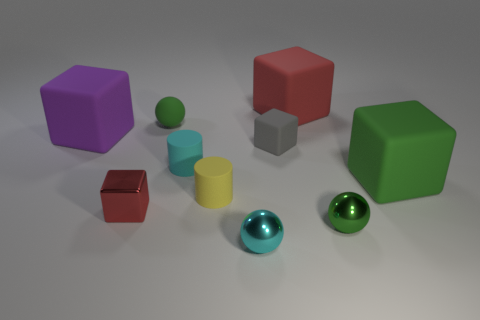The small sphere that is the same material as the small yellow object is what color?
Your answer should be compact. Green. Does the small matte thing to the right of the cyan shiny thing have the same shape as the yellow rubber thing?
Your answer should be compact. No. What number of objects are either tiny green balls behind the large green cube or tiny metal things on the left side of the tiny green metal ball?
Offer a very short reply. 3. There is another small rubber thing that is the same shape as the purple rubber thing; what color is it?
Your response must be concise. Gray. Is there anything else that has the same shape as the big green object?
Offer a terse response. Yes. Does the tiny green rubber object have the same shape as the large thing that is behind the big purple rubber thing?
Your response must be concise. No. What material is the small gray cube?
Provide a succinct answer. Rubber. What is the size of the red metallic object that is the same shape as the small gray object?
Ensure brevity in your answer.  Small. How many other things are the same material as the big red object?
Your answer should be compact. 6. Do the small gray cube and the green sphere in front of the small red object have the same material?
Provide a short and direct response. No. 